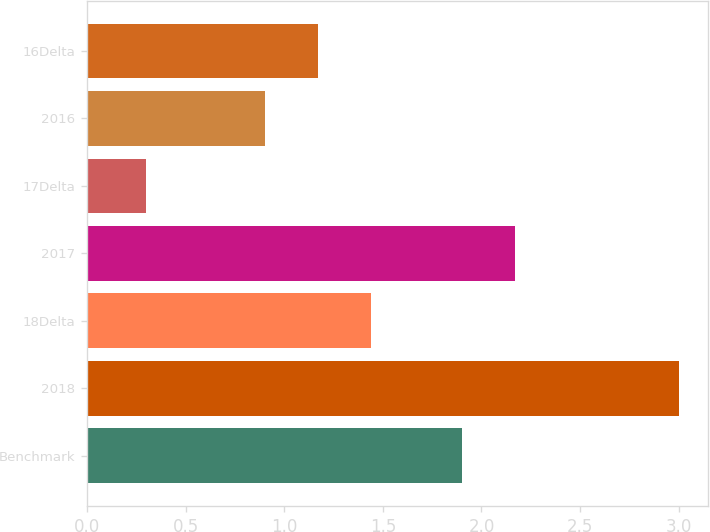Convert chart. <chart><loc_0><loc_0><loc_500><loc_500><bar_chart><fcel>Benchmark<fcel>2018<fcel>18Delta<fcel>2017<fcel>17Delta<fcel>2016<fcel>16Delta<nl><fcel>1.9<fcel>3<fcel>1.44<fcel>2.17<fcel>0.3<fcel>0.9<fcel>1.17<nl></chart> 